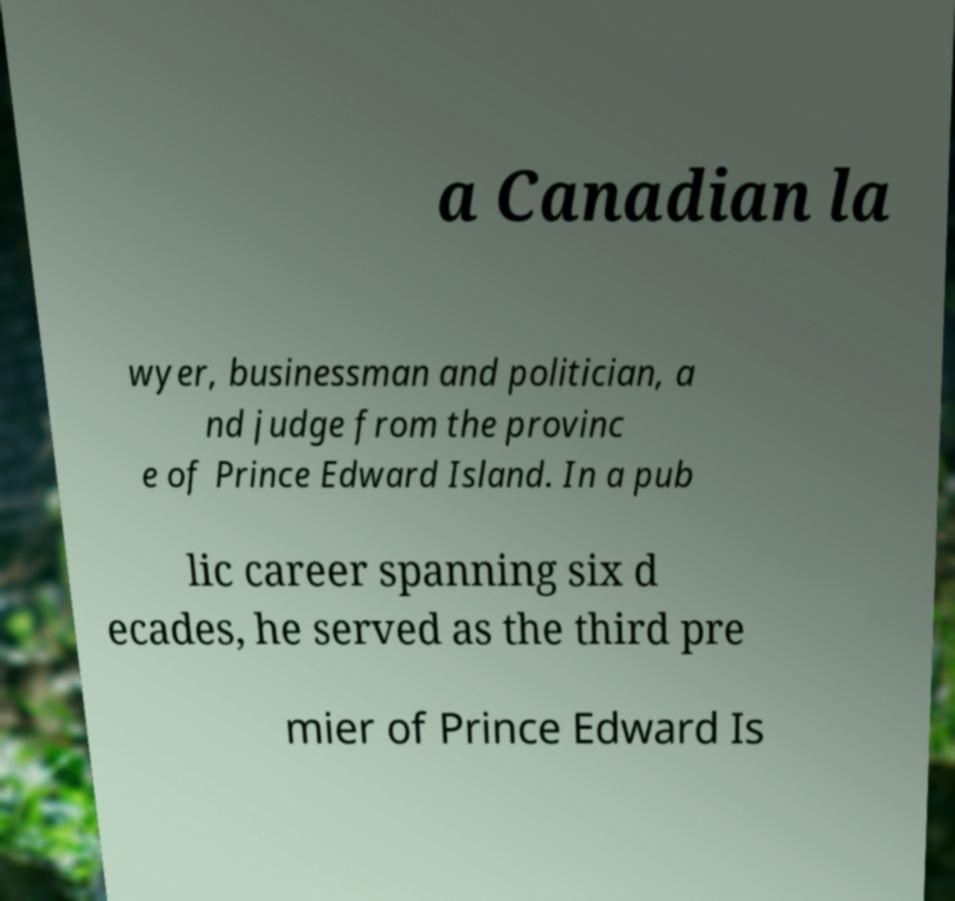I need the written content from this picture converted into text. Can you do that? a Canadian la wyer, businessman and politician, a nd judge from the provinc e of Prince Edward Island. In a pub lic career spanning six d ecades, he served as the third pre mier of Prince Edward Is 